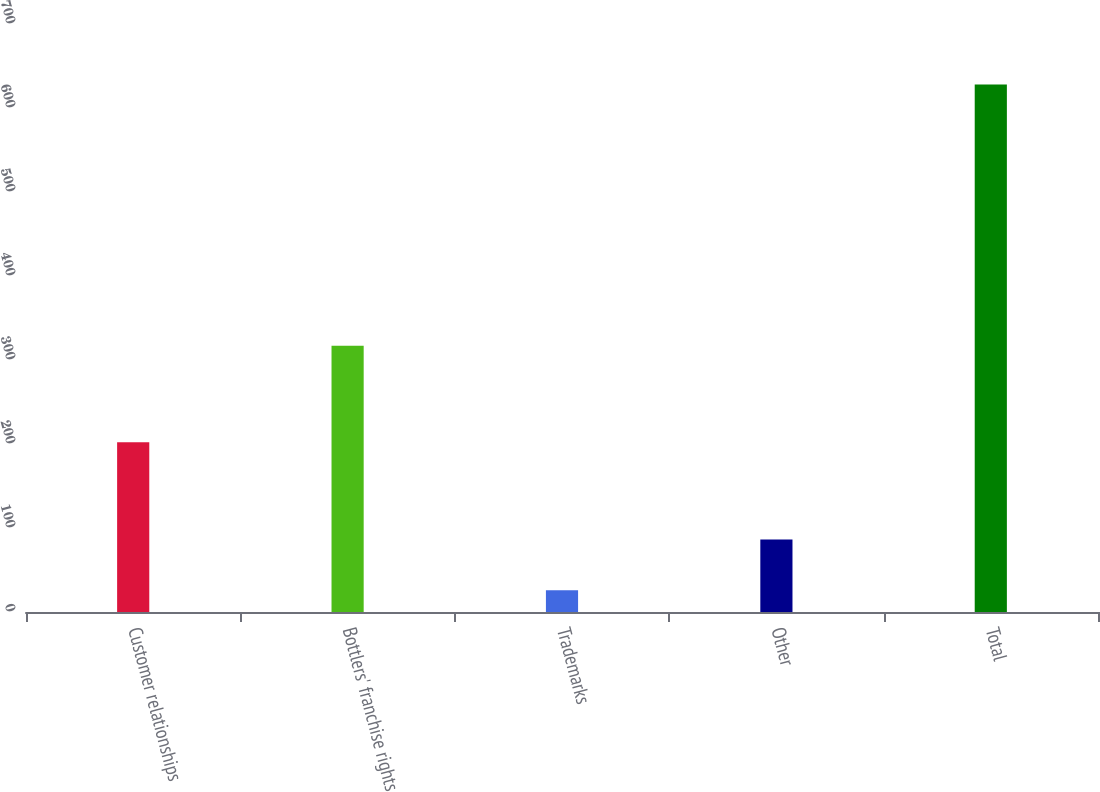<chart> <loc_0><loc_0><loc_500><loc_500><bar_chart><fcel>Customer relationships<fcel>Bottlers' franchise rights<fcel>Trademarks<fcel>Other<fcel>Total<nl><fcel>202<fcel>317<fcel>26<fcel>86.2<fcel>628<nl></chart> 